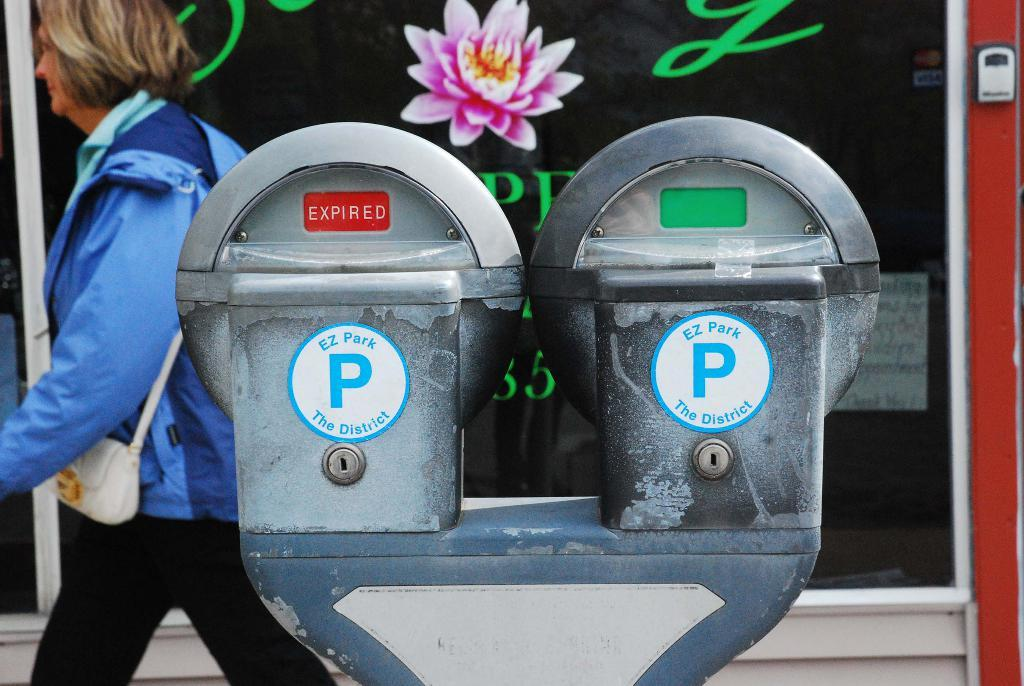<image>
Relay a brief, clear account of the picture shown. Parking meter on a street with one that says Expired. 